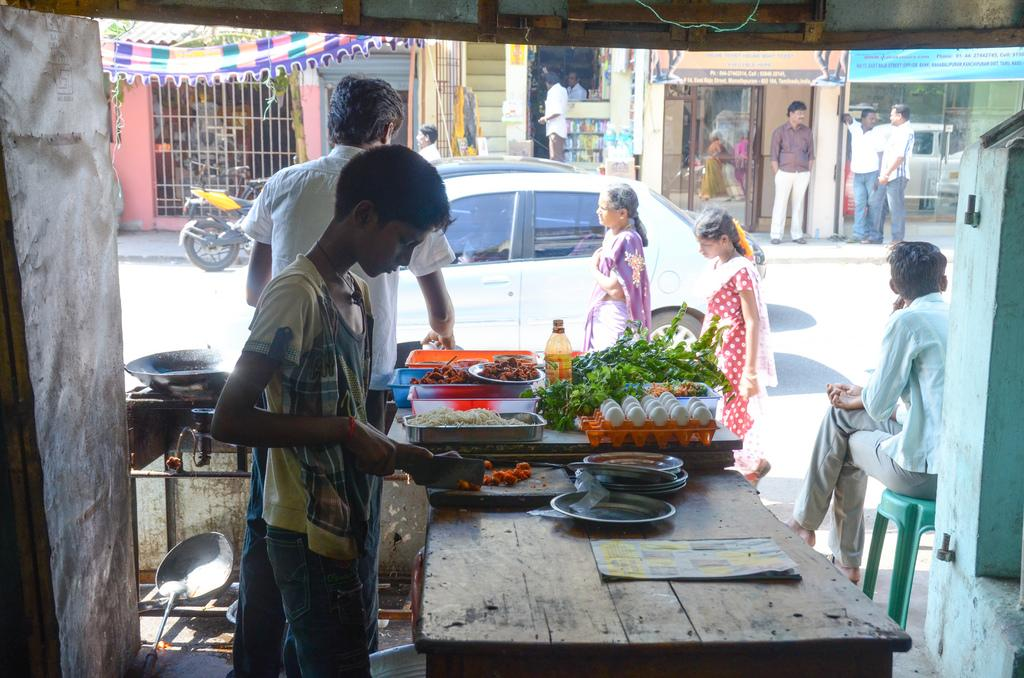Summarize the primary action taking place in the image. A boy is preparing food by slicing vegetables, with eggs present on the table. Comment on the contents of the image, specifically mentioning the main subject and his actions. In the image, a boy is engaged in slicing vegetables with a knife while standing at a table displaying a tray of eggs. Describe the most noticeable activity involving the boy in the image. The boy is using a knife to cut vegetables on a board, with a tray of eggs placed on the wooden table. State what the boy in the image is holding and doing. The boy is holding a knife and chopping vegetables on a table with eggs. Mention a highlighted activity in the image and some of the key elements around it. A young boy is chopping orange vegetables on a board, while a crate of white eggs sits on the table. Create a short sentence capturing the essence of the image. Boy with knife chops vegetables at table with egg tray. Write a concise description of the primary focal point of the image. A boy is holding a knife and cutting vegetables at a wooden table with a tray of eggs nearby. Express the central activity in the image along with some relevant details. A boy is skillfully cutting vegetables with a knife on a cutting board, with a crate of white eggs on the nearby table. Give a brief overview of the scene in the image, focusing on the boy. A boy at a wooden table is cutting vegetables using a knife, surrounded by a tray of eggs and various items. Describe, in simple words, what the boy in the image is doing. A boy is cutting vegetables with a knife at a table with eggs on it. Can you see a basketball hoop attached to the wall near the man standing across the street? No, it's not mentioned in the image. 